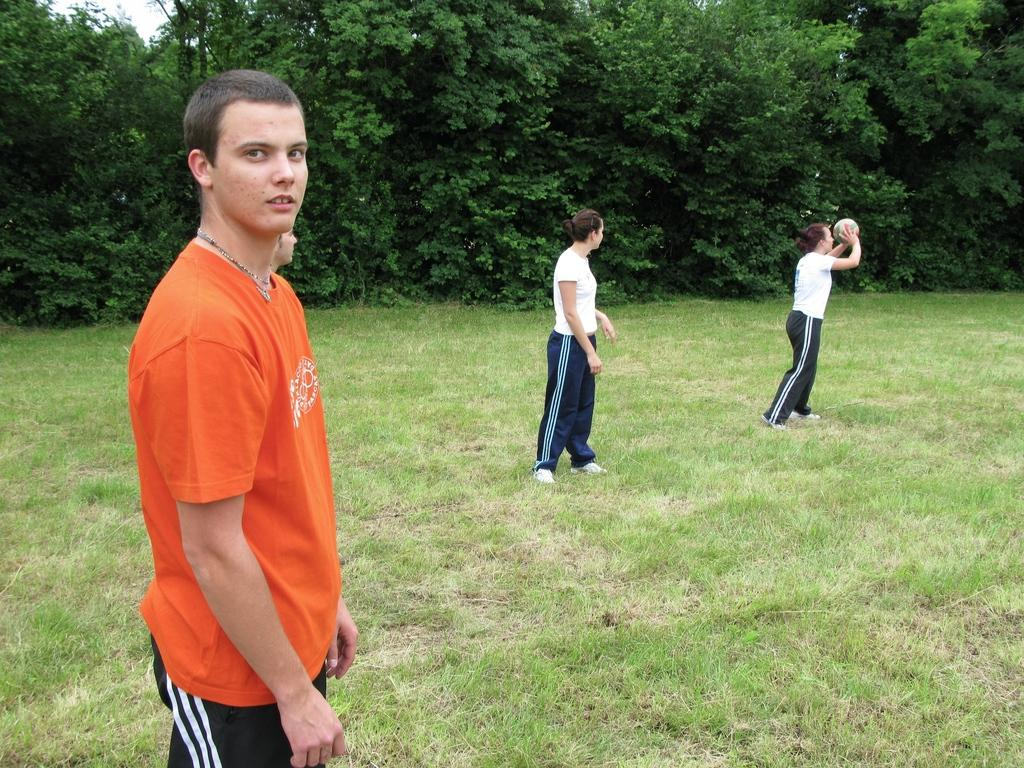How many people are standing in the image? There are four people standing in the image. What is the woman holding in the image? The woman is holding a ball in the image. What type of surface is visible under the people's feet? There is grass visible in the image. What can be seen in the background of the image? There are trees with branches and leaves in the image. What is the uncle doing with his hands in the image? There is no uncle present in the image, so it is not possible to answer that question. 